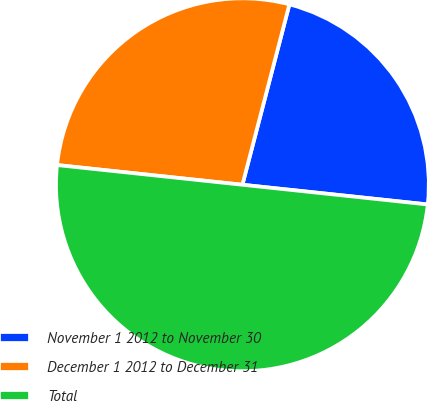Convert chart to OTSL. <chart><loc_0><loc_0><loc_500><loc_500><pie_chart><fcel>November 1 2012 to November 30<fcel>December 1 2012 to December 31<fcel>Total<nl><fcel>22.63%<fcel>27.37%<fcel>50.0%<nl></chart> 